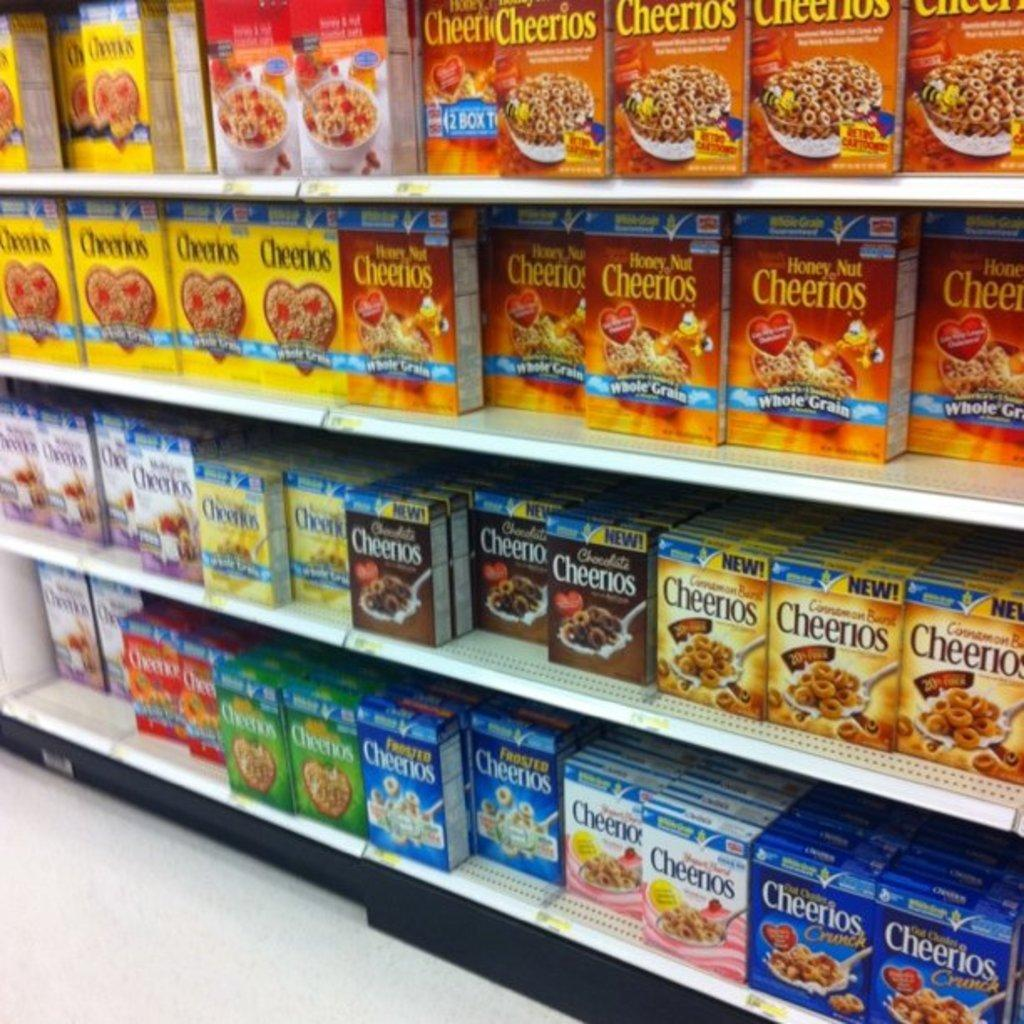<image>
Give a short and clear explanation of the subsequent image. A variety of cereal including Honey Nut Cheerios variety. 